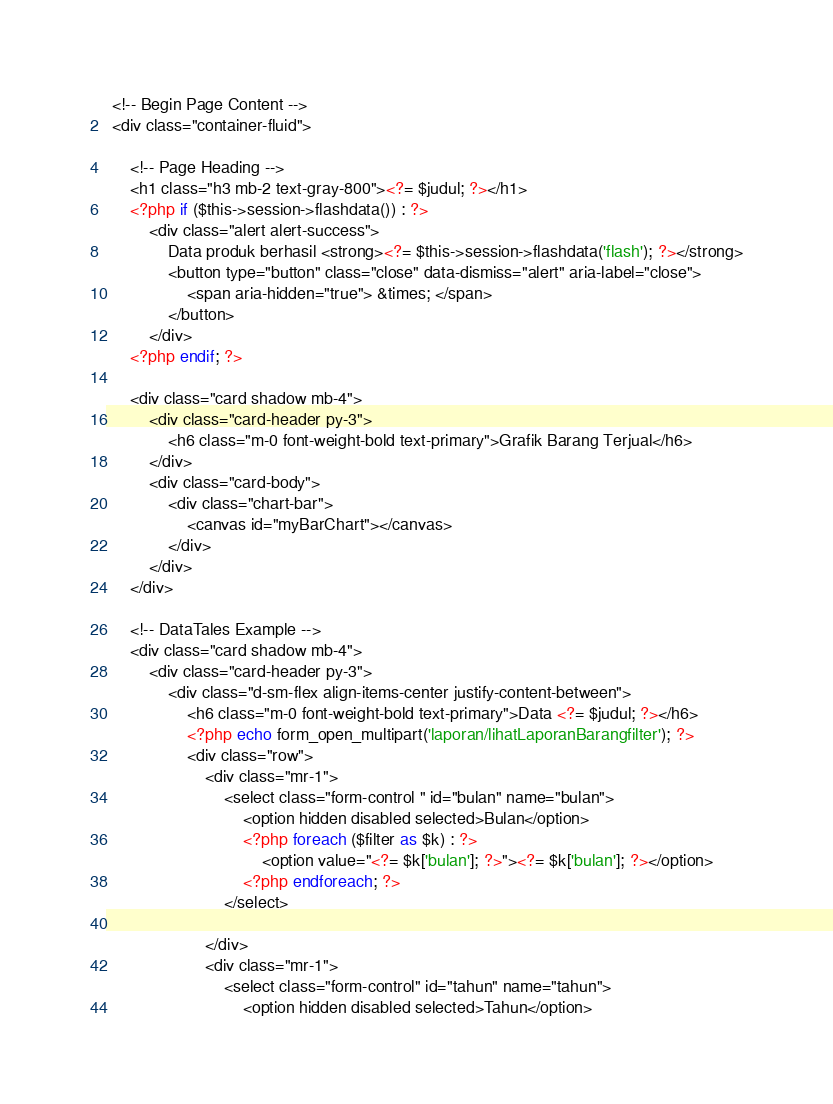<code> <loc_0><loc_0><loc_500><loc_500><_PHP_> <!-- Begin Page Content -->
 <div class="container-fluid">

     <!-- Page Heading -->
     <h1 class="h3 mb-2 text-gray-800"><?= $judul; ?></h1>
     <?php if ($this->session->flashdata()) : ?>
         <div class="alert alert-success">
             Data produk berhasil <strong><?= $this->session->flashdata('flash'); ?></strong>
             <button type="button" class="close" data-dismiss="alert" aria-label="close">
                 <span aria-hidden="true"> &times; </span>
             </button>
         </div>
     <?php endif; ?>

     <div class="card shadow mb-4">
         <div class="card-header py-3">
             <h6 class="m-0 font-weight-bold text-primary">Grafik Barang Terjual</h6>
         </div>
         <div class="card-body">
             <div class="chart-bar">
                 <canvas id="myBarChart"></canvas>
             </div>
         </div>
     </div>

     <!-- DataTales Example -->
     <div class="card shadow mb-4">
         <div class="card-header py-3">
             <div class="d-sm-flex align-items-center justify-content-between">
                 <h6 class="m-0 font-weight-bold text-primary">Data <?= $judul; ?></h6>
                 <?php echo form_open_multipart('laporan/lihatLaporanBarangfilter'); ?>
                 <div class="row">
                     <div class="mr-1">
                         <select class="form-control " id="bulan" name="bulan">
                             <option hidden disabled selected>Bulan</option>
                             <?php foreach ($filter as $k) : ?>
                                 <option value="<?= $k['bulan']; ?>"><?= $k['bulan']; ?></option>
                             <?php endforeach; ?>
                         </select>

                     </div>
                     <div class="mr-1">
                         <select class="form-control" id="tahun" name="tahun">
                             <option hidden disabled selected>Tahun</option></code> 